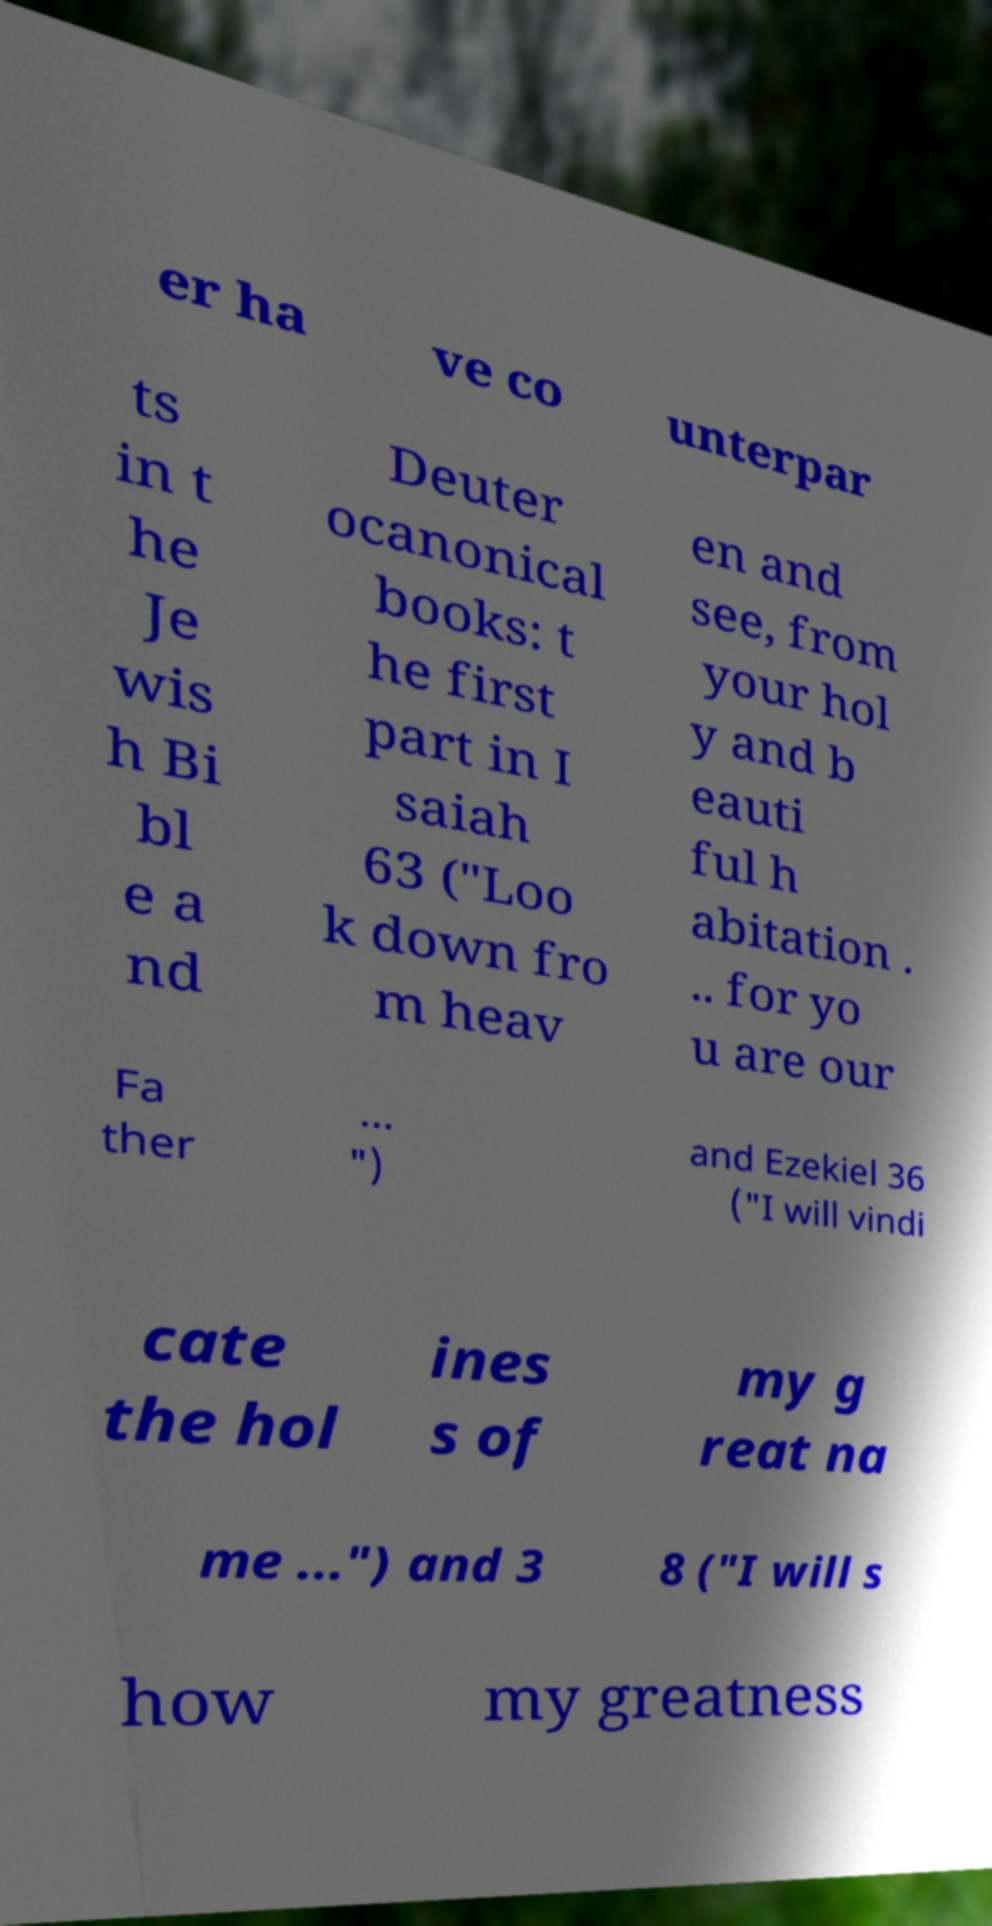Can you read and provide the text displayed in the image?This photo seems to have some interesting text. Can you extract and type it out for me? er ha ve co unterpar ts in t he Je wis h Bi bl e a nd Deuter ocanonical books: t he first part in I saiah 63 ("Loo k down fro m heav en and see, from your hol y and b eauti ful h abitation . .. for yo u are our Fa ther ... ") and Ezekiel 36 ("I will vindi cate the hol ines s of my g reat na me ...") and 3 8 ("I will s how my greatness 